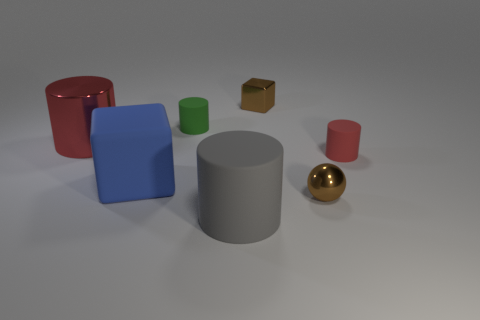Are there the same number of small brown shiny cubes that are in front of the big cube and yellow cylinders?
Give a very brief answer. Yes. There is a shiny thing that is the same shape as the small green rubber object; what is its size?
Make the answer very short. Large. There is a large gray rubber object; is it the same shape as the red thing on the left side of the metal ball?
Make the answer very short. Yes. There is a red cylinder that is to the right of the brown metal thing in front of the large metal cylinder; how big is it?
Offer a very short reply. Small. Are there the same number of tiny matte cylinders that are on the right side of the green rubber object and brown shiny things that are on the right side of the metallic block?
Ensure brevity in your answer.  Yes. The other shiny object that is the same shape as the blue object is what color?
Provide a succinct answer. Brown. What number of big cubes have the same color as the big matte cylinder?
Your answer should be compact. 0. Is the shape of the tiny matte thing that is to the left of the large gray thing the same as  the gray thing?
Your response must be concise. Yes. There is a tiny rubber thing that is on the left side of the brown metal thing behind the small metal thing that is in front of the large red thing; what is its shape?
Keep it short and to the point. Cylinder. The blue matte object has what size?
Give a very brief answer. Large. 